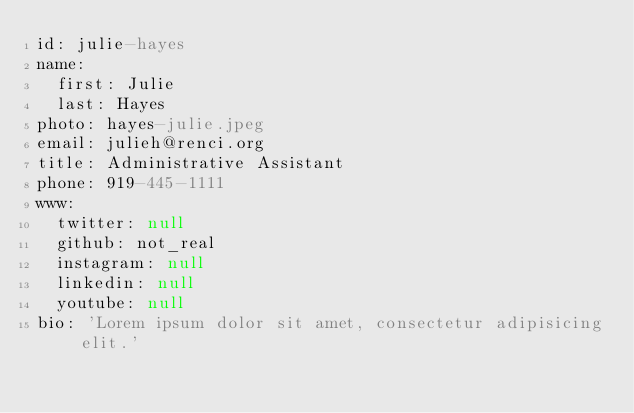<code> <loc_0><loc_0><loc_500><loc_500><_YAML_>id: julie-hayes
name: 
  first: Julie
  last: Hayes
photo: hayes-julie.jpeg
email: julieh@renci.org
title: Administrative Assistant
phone: 919-445-1111
www:
  twitter: null
  github: not_real
  instagram: null
  linkedin: null
  youtube: null
bio: 'Lorem ipsum dolor sit amet, consectetur adipisicing elit.'</code> 